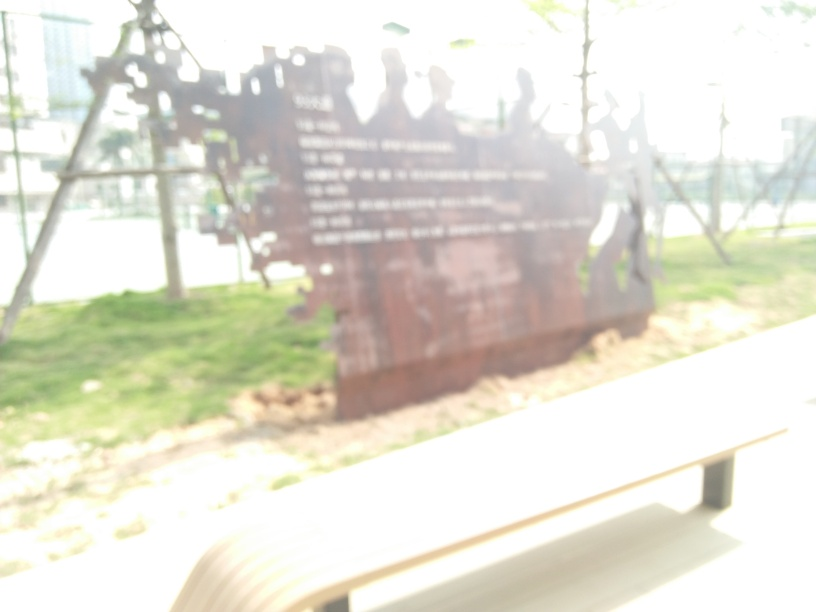Are there any discernible shapes or figures in the image that you can describe? There is a vague outline of what appears to be a group of figures, possibly statues or people, and some linear elements that could be part of a structure or installation. However, the blurriness obscures any fine details, making it hard to provide a precise description. 